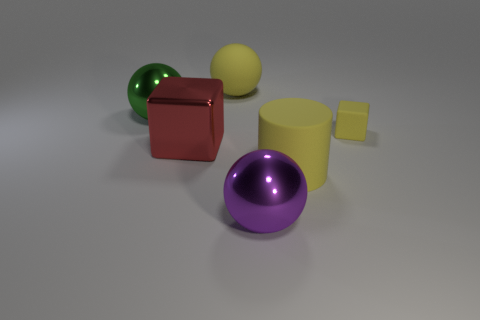Subtract all blocks. How many objects are left? 4 Add 2 gray cylinders. How many objects exist? 8 Add 3 yellow objects. How many yellow objects are left? 6 Add 1 small red cubes. How many small red cubes exist? 1 Subtract 0 blue spheres. How many objects are left? 6 Subtract all matte cubes. Subtract all yellow rubber blocks. How many objects are left? 4 